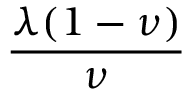Convert formula to latex. <formula><loc_0><loc_0><loc_500><loc_500>\frac { \lambda ( 1 - \nu ) } { \nu }</formula> 